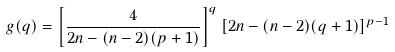Convert formula to latex. <formula><loc_0><loc_0><loc_500><loc_500>g ( q ) = \left [ \frac { 4 } { 2 n - ( n - 2 ) ( p + 1 ) } \right ] ^ { q } [ 2 n - ( n - 2 ) ( q + 1 ) ] ^ { p - 1 }</formula> 